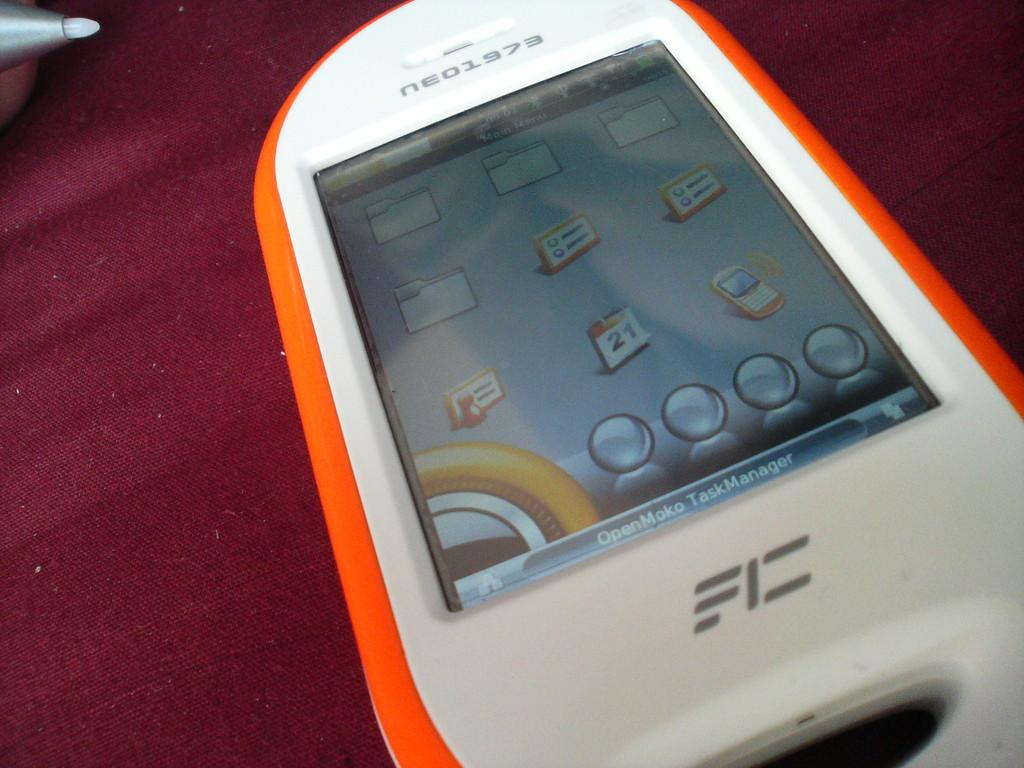<image>
Provide a brief description of the given image. An orange phone says neo1973 at the top 